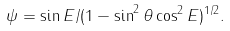<formula> <loc_0><loc_0><loc_500><loc_500>\psi = \sin E / ( 1 - \sin ^ { 2 } \theta \cos ^ { 2 } E ) ^ { 1 / 2 } .</formula> 